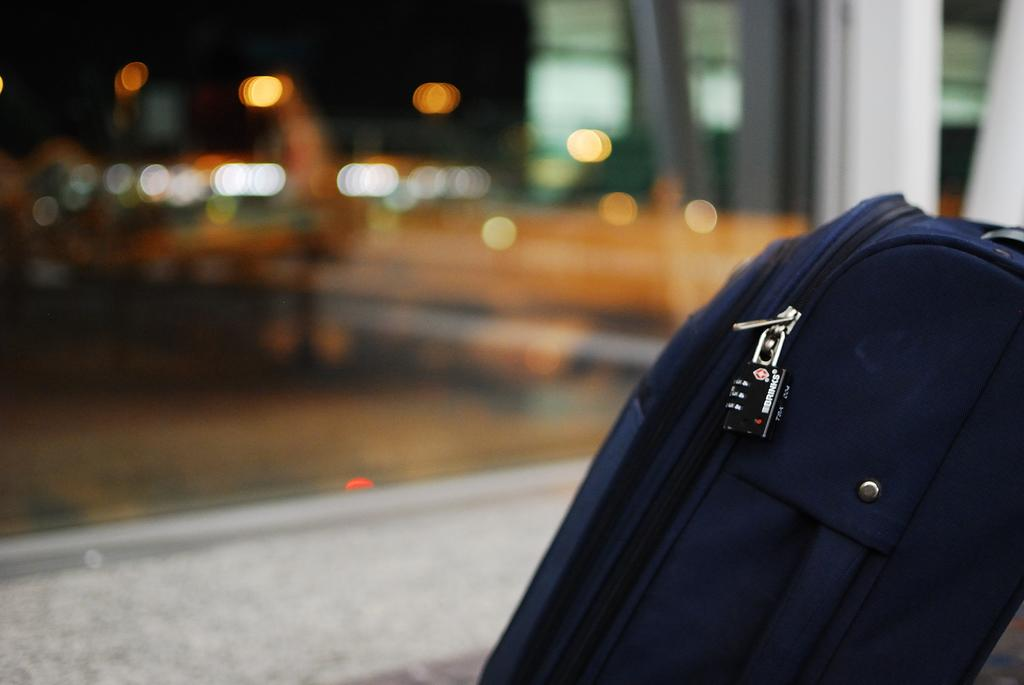What object is located in the foreground of the image? There is a bag in the foreground of the image. Can you describe the background of the image? The background of the image is blurry. What type of wheel can be seen in the image? There is no wheel present in the image. How does the steam affect the appearance of the bag in the image? There is no steam present in the image, so it does not affect the appearance of the bag. 